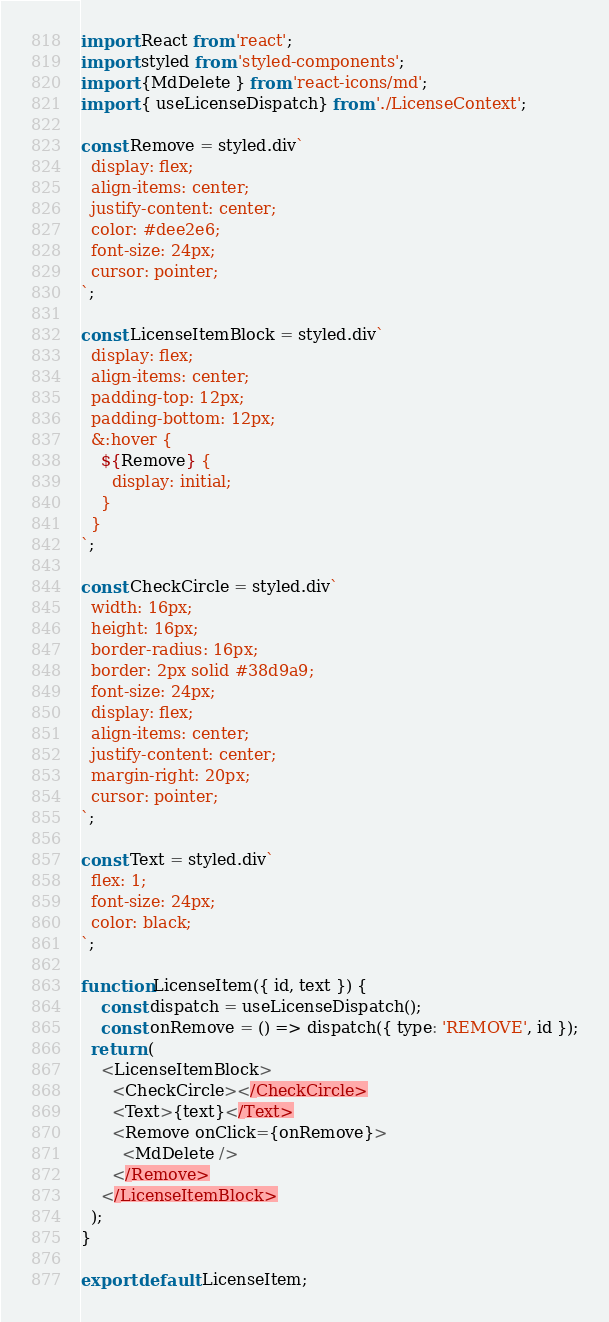<code> <loc_0><loc_0><loc_500><loc_500><_JavaScript_>import React from 'react';
import styled from 'styled-components';
import {MdDelete } from 'react-icons/md';
import { useLicenseDispatch} from './LicenseContext';

const Remove = styled.div`
  display: flex;
  align-items: center;
  justify-content: center;
  color: #dee2e6;
  font-size: 24px;
  cursor: pointer;
`;

const LicenseItemBlock = styled.div`
  display: flex;
  align-items: center;
  padding-top: 12px;
  padding-bottom: 12px;
  &:hover {
    ${Remove} {
      display: initial;
    }
  }
`;

const CheckCircle = styled.div`
  width: 16px;
  height: 16px;
  border-radius: 16px;
  border: 2px solid #38d9a9;
  font-size: 24px;
  display: flex;
  align-items: center;
  justify-content: center;
  margin-right: 20px;
  cursor: pointer;
`;

const Text = styled.div`
  flex: 1;
  font-size: 24px;
  color: black;
`;

function LicenseItem({ id, text }) {
    const dispatch = useLicenseDispatch();
    const onRemove = () => dispatch({ type: 'REMOVE', id });
  return (
    <LicenseItemBlock>
      <CheckCircle></CheckCircle>
      <Text>{text}</Text>
      <Remove onClick={onRemove}>
        <MdDelete />
      </Remove>
    </LicenseItemBlock>
  );
}

export default LicenseItem;</code> 